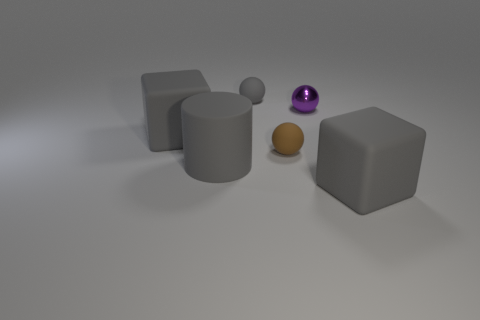Add 3 things. How many objects exist? 9 Subtract all cylinders. How many objects are left? 5 Subtract 0 red balls. How many objects are left? 6 Subtract all tiny metal things. Subtract all cylinders. How many objects are left? 4 Add 6 gray cubes. How many gray cubes are left? 8 Add 1 green shiny cubes. How many green shiny cubes exist? 1 